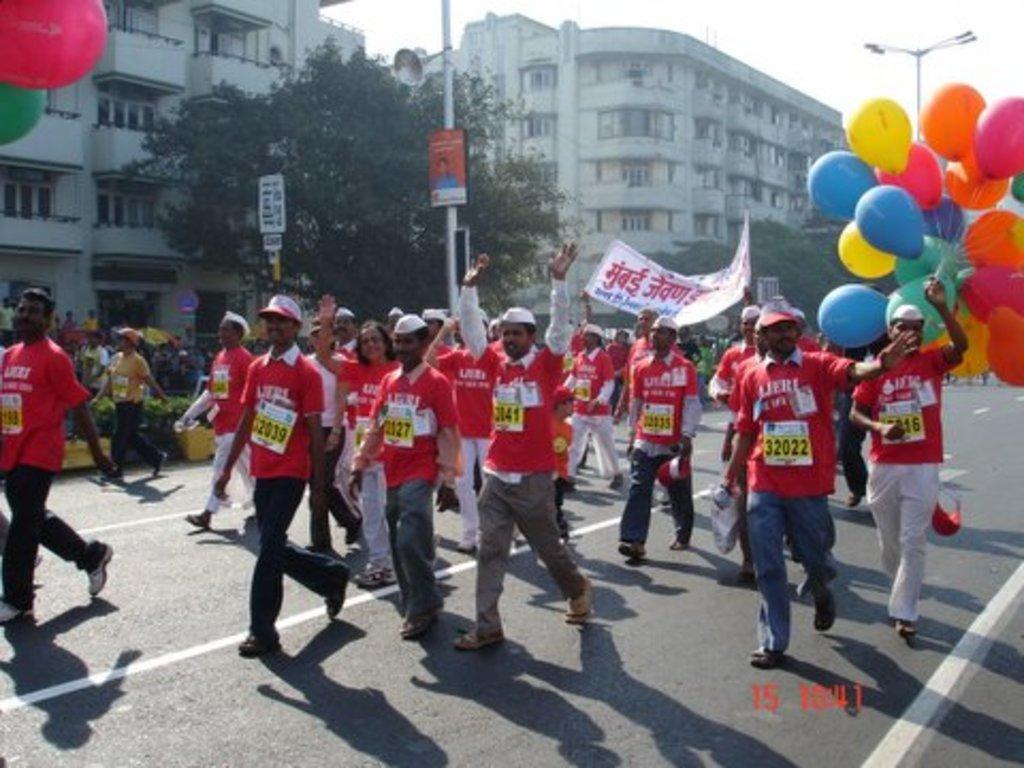Describe this image in one or two sentences. In this image we can see some group of persons wearing red color T-shirt, holding some balloons, boards in their hands walking through the road and on left side of the image there are some buildings, trees, lights and clear sky. 